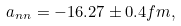<formula> <loc_0><loc_0><loc_500><loc_500>a _ { n n } = - 1 6 . 2 7 \pm 0 . 4 f m ,</formula> 